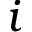Convert formula to latex. <formula><loc_0><loc_0><loc_500><loc_500>i</formula> 